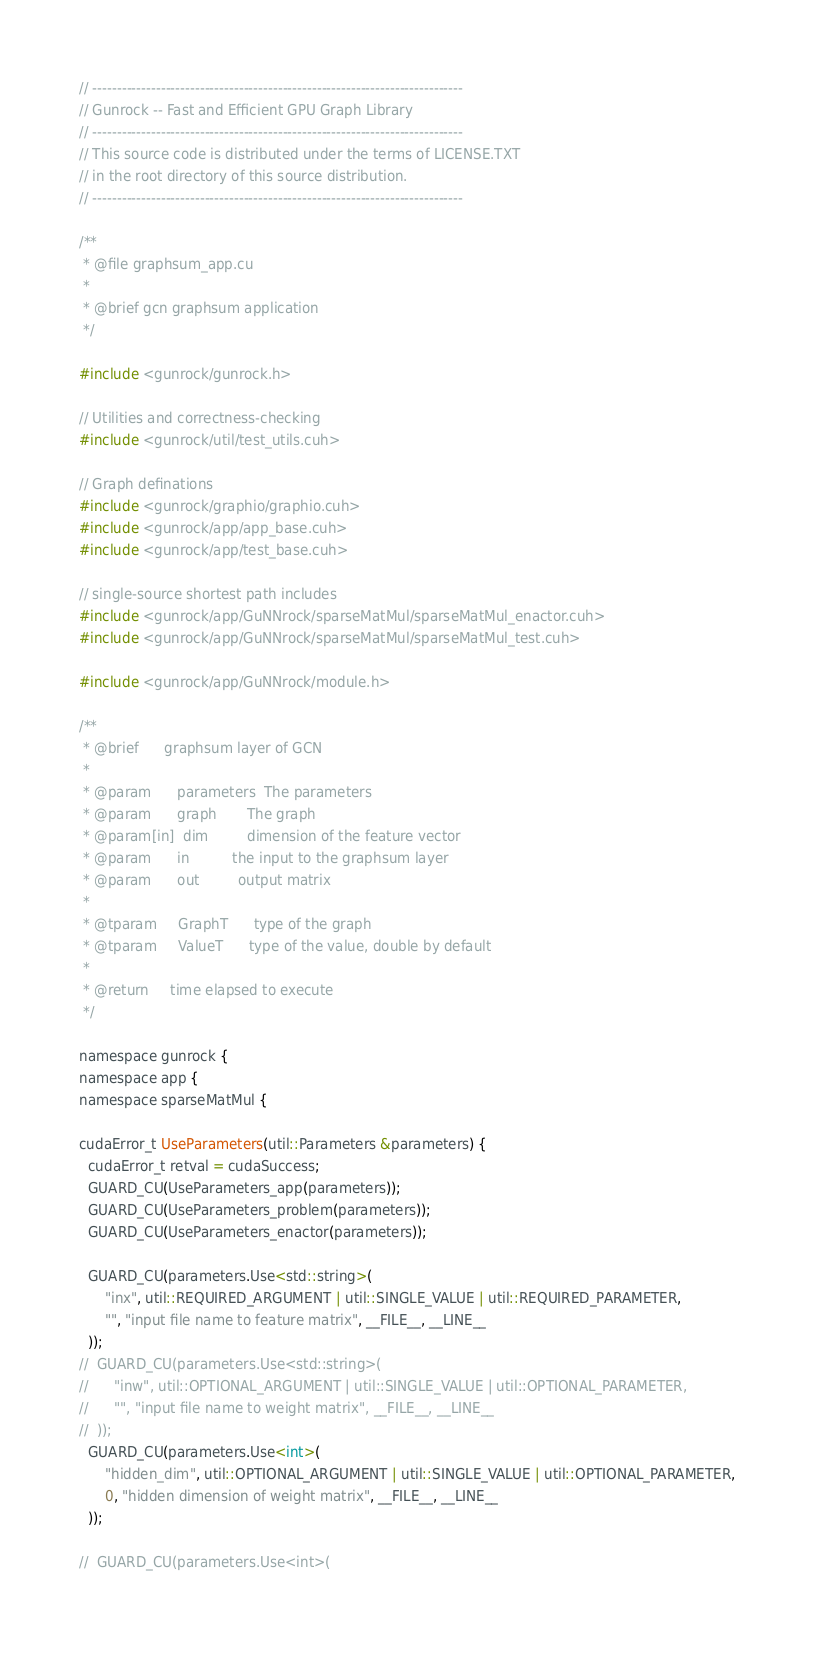Convert code to text. <code><loc_0><loc_0><loc_500><loc_500><_Cuda_>// ----------------------------------------------------------------------------
// Gunrock -- Fast and Efficient GPU Graph Library
// ----------------------------------------------------------------------------
// This source code is distributed under the terms of LICENSE.TXT
// in the root directory of this source distribution.
// ----------------------------------------------------------------------------

/**
 * @file graphsum_app.cu
 *
 * @brief gcn graphsum application
 */

#include <gunrock/gunrock.h>

// Utilities and correctness-checking
#include <gunrock/util/test_utils.cuh>

// Graph definations
#include <gunrock/graphio/graphio.cuh>
#include <gunrock/app/app_base.cuh>
#include <gunrock/app/test_base.cuh>

// single-source shortest path includes
#include <gunrock/app/GuNNrock/sparseMatMul/sparseMatMul_enactor.cuh>
#include <gunrock/app/GuNNrock/sparseMatMul/sparseMatMul_test.cuh>

#include <gunrock/app/GuNNrock/module.h>

/**
 * @brief      graphsum layer of GCN
 *
 * @param      parameters  The parameters
 * @param      graph       The graph
 * @param[in]  dim         dimension of the feature vector
 * @param      in          the input to the graphsum layer
 * @param      out         output matrix
 *
 * @tparam     GraphT      type of the graph
 * @tparam     ValueT      type of the value, double by default
 *
 * @return     time elapsed to execute
 */

namespace gunrock {
namespace app {
namespace sparseMatMul {

cudaError_t UseParameters(util::Parameters &parameters) {
  cudaError_t retval = cudaSuccess;
  GUARD_CU(UseParameters_app(parameters));
  GUARD_CU(UseParameters_problem(parameters));
  GUARD_CU(UseParameters_enactor(parameters));

  GUARD_CU(parameters.Use<std::string>(
      "inx", util::REQUIRED_ARGUMENT | util::SINGLE_VALUE | util::REQUIRED_PARAMETER,
      "", "input file name to feature matrix", __FILE__, __LINE__
  ));
//  GUARD_CU(parameters.Use<std::string>(
//      "inw", util::OPTIONAL_ARGUMENT | util::SINGLE_VALUE | util::OPTIONAL_PARAMETER,
//      "", "input file name to weight matrix", __FILE__, __LINE__
//  ));
  GUARD_CU(parameters.Use<int>(
      "hidden_dim", util::OPTIONAL_ARGUMENT | util::SINGLE_VALUE | util::OPTIONAL_PARAMETER,
      0, "hidden dimension of weight matrix", __FILE__, __LINE__
  ));

//  GUARD_CU(parameters.Use<int>(</code> 